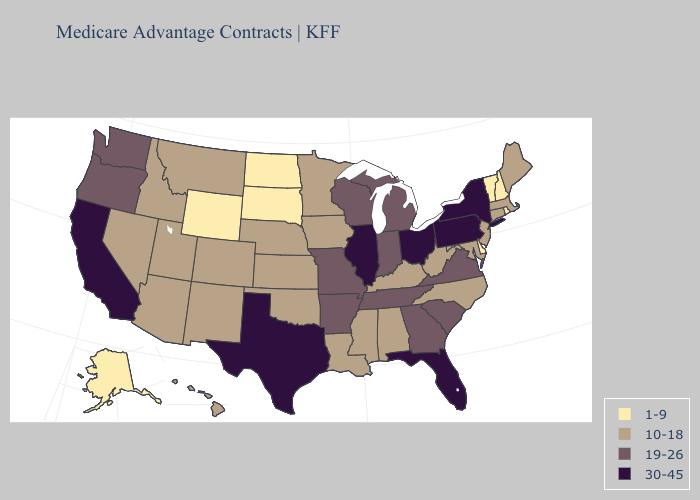What is the highest value in states that border Tennessee?
Write a very short answer. 19-26. Name the states that have a value in the range 1-9?
Be succinct. Alaska, Delaware, North Dakota, New Hampshire, Rhode Island, South Dakota, Vermont, Wyoming. Name the states that have a value in the range 30-45?
Be succinct. California, Florida, Illinois, New York, Ohio, Pennsylvania, Texas. What is the value of Alabama?
Short answer required. 10-18. What is the highest value in the USA?
Answer briefly. 30-45. Which states have the lowest value in the South?
Give a very brief answer. Delaware. Does the first symbol in the legend represent the smallest category?
Answer briefly. Yes. Does Georgia have the highest value in the South?
Quick response, please. No. Among the states that border Georgia , does Florida have the highest value?
Answer briefly. Yes. Name the states that have a value in the range 1-9?
Be succinct. Alaska, Delaware, North Dakota, New Hampshire, Rhode Island, South Dakota, Vermont, Wyoming. What is the value of Massachusetts?
Short answer required. 10-18. Does the first symbol in the legend represent the smallest category?
Answer briefly. Yes. Name the states that have a value in the range 10-18?
Answer briefly. Alabama, Arizona, Colorado, Connecticut, Hawaii, Iowa, Idaho, Kansas, Kentucky, Louisiana, Massachusetts, Maryland, Maine, Minnesota, Mississippi, Montana, North Carolina, Nebraska, New Jersey, New Mexico, Nevada, Oklahoma, Utah, West Virginia. Which states have the lowest value in the USA?
Give a very brief answer. Alaska, Delaware, North Dakota, New Hampshire, Rhode Island, South Dakota, Vermont, Wyoming. What is the value of Illinois?
Be succinct. 30-45. 